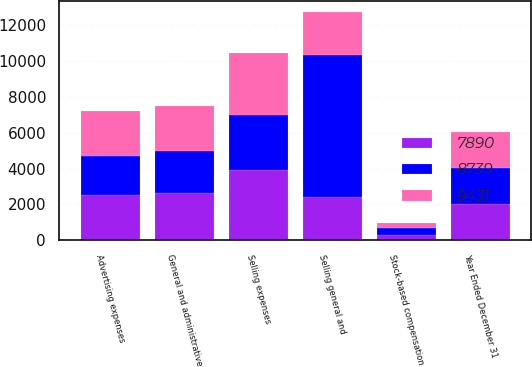Convert chart. <chart><loc_0><loc_0><loc_500><loc_500><stacked_bar_chart><ecel><fcel>Year Ended December 31<fcel>Selling expenses<fcel>Advertising expenses<fcel>General and administrative<fcel>Stock-based compensation<fcel>Selling general and<nl><fcel>7890<fcel>2006<fcel>3924<fcel>2553<fcel>2630<fcel>324<fcel>2412<nl><fcel>9431<fcel>2005<fcel>3453<fcel>2475<fcel>2487<fcel>324<fcel>2412<nl><fcel>8739<fcel>2004<fcel>3031<fcel>2165<fcel>2349<fcel>345<fcel>7890<nl></chart> 